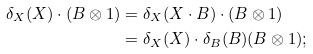Convert formula to latex. <formula><loc_0><loc_0><loc_500><loc_500>\delta _ { X } ( X ) \cdot ( B \otimes 1 ) & = \delta _ { X } ( X \cdot B ) \cdot ( B \otimes 1 ) \\ & = \delta _ { X } ( X ) \cdot \delta _ { B } ( B ) ( B \otimes 1 ) ;</formula> 